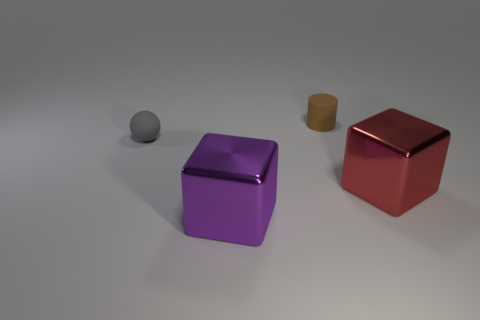How many shiny things are there?
Give a very brief answer. 2. What is the shape of the object that is behind the red metallic thing and right of the tiny matte sphere?
Offer a terse response. Cylinder. There is a metal block on the right side of the tiny cylinder; is it the same color as the tiny object behind the small gray matte ball?
Your response must be concise. No. Is there a brown cube made of the same material as the ball?
Give a very brief answer. No. Are there the same number of tiny brown matte cylinders on the left side of the tiny matte sphere and big red things that are behind the small brown cylinder?
Provide a succinct answer. Yes. There is a block that is left of the small brown rubber thing; what size is it?
Provide a short and direct response. Large. There is a block on the right side of the small object behind the gray sphere; what is it made of?
Your answer should be very brief. Metal. What number of purple blocks are left of the large block that is to the left of the matte thing that is behind the small sphere?
Offer a terse response. 0. Are the block that is left of the big red cube and the large cube to the right of the purple cube made of the same material?
Make the answer very short. Yes. What number of large purple metal things have the same shape as the big red shiny thing?
Make the answer very short. 1. 